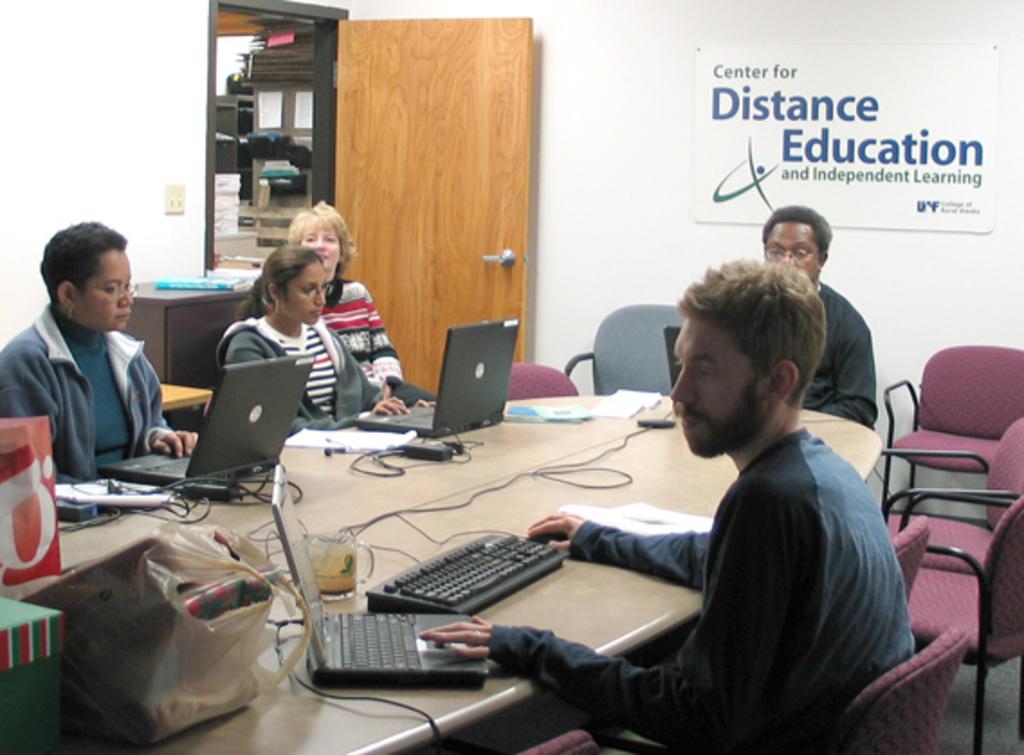What kind of center is this?
Provide a short and direct response. Distance education. Is the learning here independent or dependent?
Your answer should be compact. Independent. 